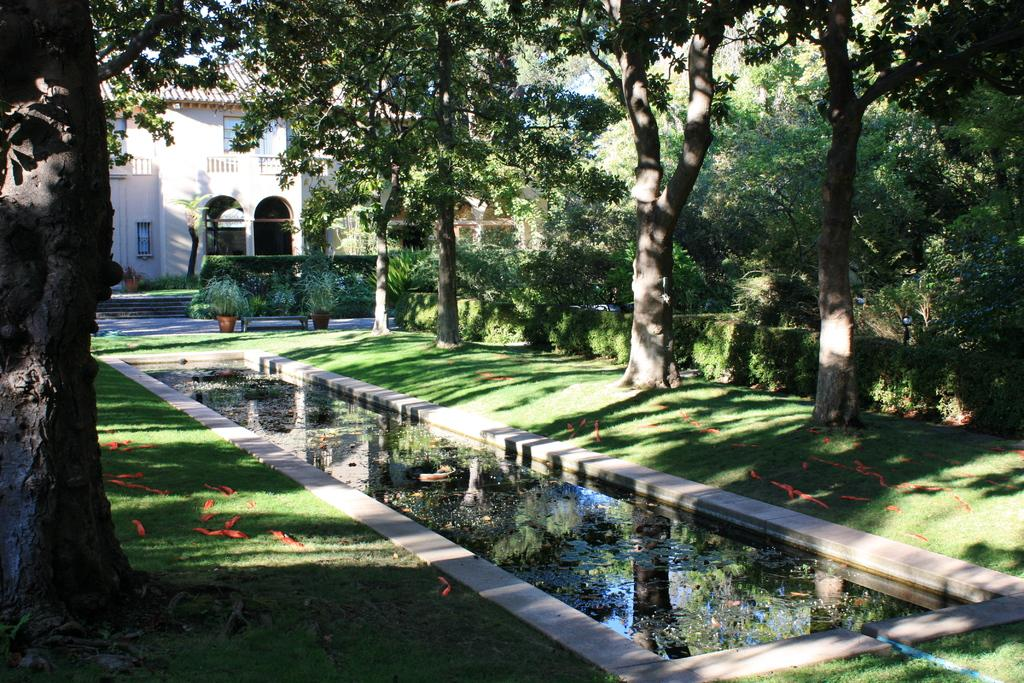What is one of the natural elements present in the image? There is water in the image. What type of vegetation can be seen in the image? There are plants, grass, and trees in the image. What type of structure is visible in the image? There is a building in the image. Are there any architectural features present in the image? Yes, there is a staircase in the image. What type of meat is being grilled on the hill in the image? There is no hill or meat present in the image. What day of the week is depicted in the image? The day of the week is not mentioned or depicted in the image. 